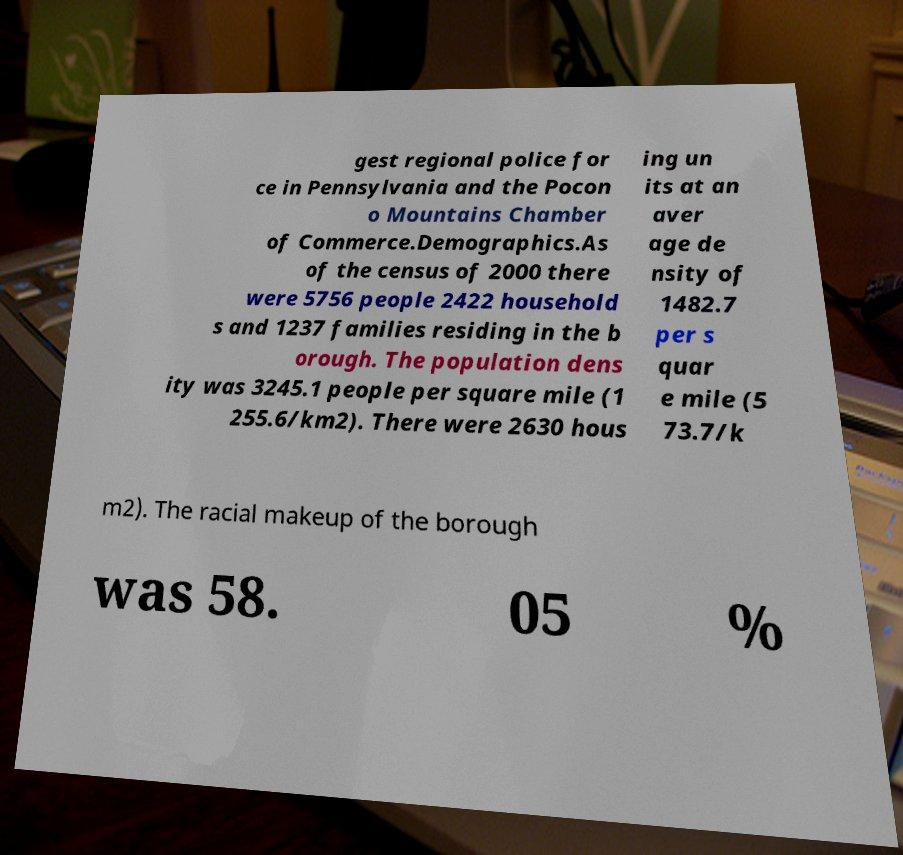Could you extract and type out the text from this image? gest regional police for ce in Pennsylvania and the Pocon o Mountains Chamber of Commerce.Demographics.As of the census of 2000 there were 5756 people 2422 household s and 1237 families residing in the b orough. The population dens ity was 3245.1 people per square mile (1 255.6/km2). There were 2630 hous ing un its at an aver age de nsity of 1482.7 per s quar e mile (5 73.7/k m2). The racial makeup of the borough was 58. 05 % 